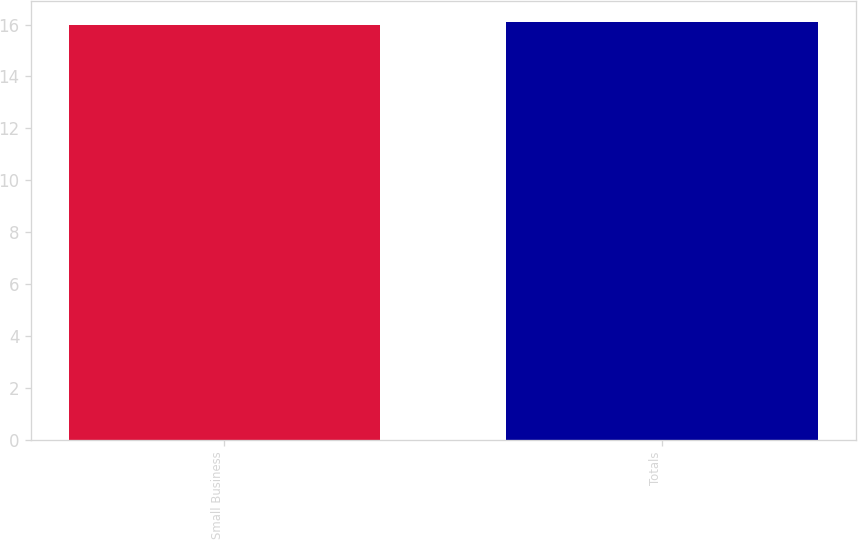Convert chart to OTSL. <chart><loc_0><loc_0><loc_500><loc_500><bar_chart><fcel>Small Business<fcel>Totals<nl><fcel>16<fcel>16.1<nl></chart> 